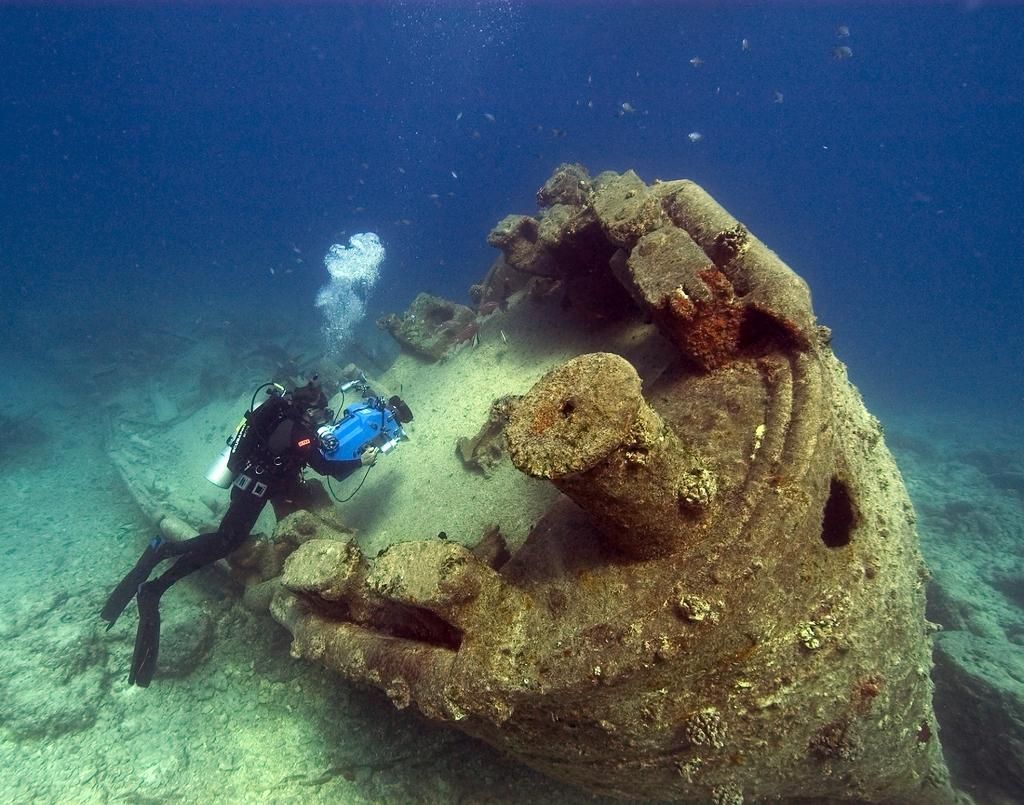What is the person in the image doing? The person is underwater in the image. What is the person holding while underwater? The person is holding a machine. What else can be seen in the water in the image? There is a piece of a boat in the water in the image. What type of cord is being used to power the attraction in the image? There is no attraction or cord present in the image; it features a person underwater holding a machine and a piece of a boat in the water. 